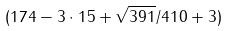<formula> <loc_0><loc_0><loc_500><loc_500>( 1 7 4 - 3 \cdot 1 5 + \sqrt { 3 9 1 } / 4 1 0 + 3 )</formula> 